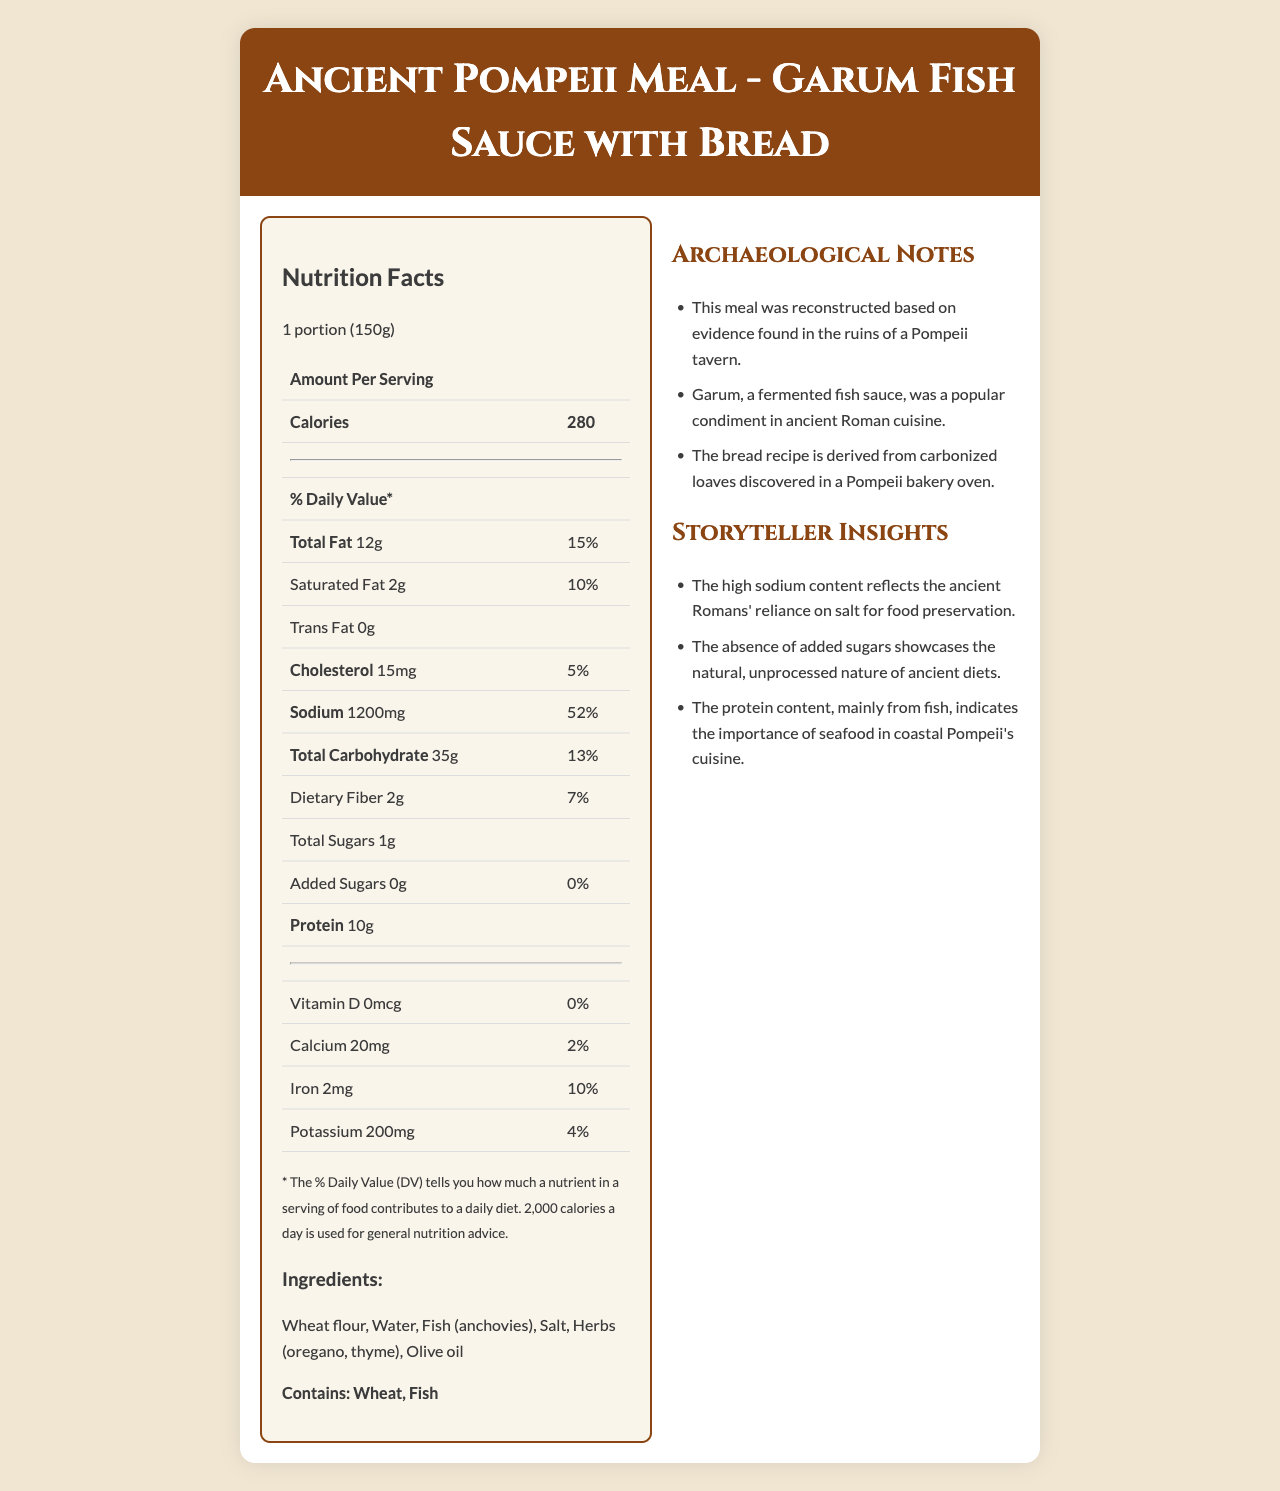What is the serving size of "Ancient Pompeii Meal - Garum Fish Sauce with Bread"? The serving size is clearly stated as "1 portion (150g)" at the beginning of the document.
Answer: 1 portion (150g) How many calories are there per serving? The document mentions 280 calories per serving in the "Amount Per Serving" section.
Answer: 280 What is the total fat content per serving, and what is the daily value percentage? The total fat content per serving is 12g, which is 15% of the daily value.
Answer: 12g, 15% How much sodium is in one serving of this meal? The sodium content is listed as 1200mg per serving.
Answer: 1200mg List the main ingredients found in this meal. The ingredients section lists these six main components.
Answer: Wheat flour, Water, Fish (anchovies), Salt, Herbs (oregano, thyme), Olive oil Which of the following is true about the meal's protein content? a) It has 5g of protein. b) It has 10g of protein. c) It has 15g of protein. d) It contains no protein. The protein content per serving is given as 10g in the document.
Answer: b) It has 10g of protein. Which nutrient has the highest daily value percentage? a) Total Fat b) Sodium c) Total Carbohydrate d) Cholesterol The daily value percentage of sodium is 52%, which is higher than the other listed nutrients.
Answer: b) Sodium Does the meal contain any added sugars? The document specifies that there are "0g" of added sugars, translating to a 0% daily value.
Answer: No Is this meal suitable for someone with a wheat allergy? The allergens section notes that the meal contains wheat.
Answer: No Summarize the main idea of this document. The document includes nutritional facts, ingredients, allergens, archaeological notes, and storyteller insights that present a comprehensive view of the meal and its historical significance.
Answer: The document provides detailed nutritional information about an "Ancient Pompeii Meal - Garum Fish Sauce with Bread", highlighting its calorie count, macronutrient composition, ingredients, and historical context related to Pompeii. What is the daily value percentage of calcium in this meal? The calcium content is 20mg per serving, which equals 2% of the daily value.
Answer: 2% What are the two key historical details about this meal stated in the archaeological notes? The notes explain that Garum was a popular condiment in ancient Roman cuisine, and the bread recipe was derived from carbonized loaves found in a Pompeii bakery oven.
Answer: Garum was a popular condiment, and the bread recipe is from carbonized loaves discovered in Pompeii. Does the meal contain any trans fat? The document shows "0g" of trans fat.
Answer: No What are the herbs used in this meal? The ingredients list mentions oregano and thyme as the herbs used.
Answer: Oregano, Thyme How does the high sodium content reflect ancient Roman dietary practices? The storyteller insights mention that the high sodium content is indicative of the Romans' use of salt for preserving food.
Answer: The high sodium content reflects the ancient Romans' reliance on salt for food preservation. What is the source of protein in this meal? The ingredients list specifies fish (anchovies) as the protein source.
Answer: Fish (anchovies) 